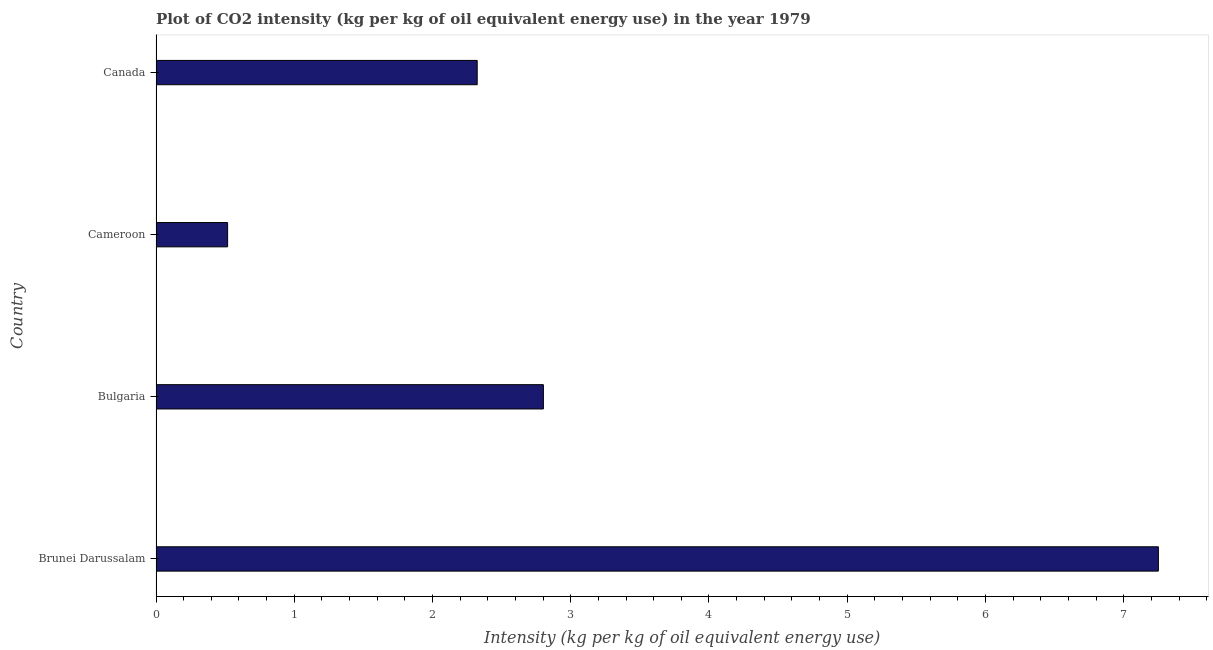Does the graph contain any zero values?
Keep it short and to the point. No. Does the graph contain grids?
Ensure brevity in your answer.  No. What is the title of the graph?
Keep it short and to the point. Plot of CO2 intensity (kg per kg of oil equivalent energy use) in the year 1979. What is the label or title of the X-axis?
Your response must be concise. Intensity (kg per kg of oil equivalent energy use). What is the label or title of the Y-axis?
Offer a very short reply. Country. What is the co2 intensity in Cameroon?
Offer a terse response. 0.52. Across all countries, what is the maximum co2 intensity?
Give a very brief answer. 7.25. Across all countries, what is the minimum co2 intensity?
Provide a short and direct response. 0.52. In which country was the co2 intensity maximum?
Your answer should be compact. Brunei Darussalam. In which country was the co2 intensity minimum?
Offer a very short reply. Cameroon. What is the sum of the co2 intensity?
Offer a terse response. 12.89. What is the difference between the co2 intensity in Brunei Darussalam and Canada?
Ensure brevity in your answer.  4.93. What is the average co2 intensity per country?
Provide a succinct answer. 3.22. What is the median co2 intensity?
Ensure brevity in your answer.  2.56. What is the ratio of the co2 intensity in Brunei Darussalam to that in Cameroon?
Ensure brevity in your answer.  14. Is the difference between the co2 intensity in Bulgaria and Cameroon greater than the difference between any two countries?
Offer a very short reply. No. What is the difference between the highest and the second highest co2 intensity?
Your answer should be very brief. 4.45. Is the sum of the co2 intensity in Brunei Darussalam and Canada greater than the maximum co2 intensity across all countries?
Keep it short and to the point. Yes. What is the difference between the highest and the lowest co2 intensity?
Ensure brevity in your answer.  6.73. Are all the bars in the graph horizontal?
Provide a succinct answer. Yes. What is the difference between two consecutive major ticks on the X-axis?
Offer a terse response. 1. What is the Intensity (kg per kg of oil equivalent energy use) of Brunei Darussalam?
Your response must be concise. 7.25. What is the Intensity (kg per kg of oil equivalent energy use) in Bulgaria?
Keep it short and to the point. 2.8. What is the Intensity (kg per kg of oil equivalent energy use) in Cameroon?
Provide a short and direct response. 0.52. What is the Intensity (kg per kg of oil equivalent energy use) in Canada?
Provide a short and direct response. 2.32. What is the difference between the Intensity (kg per kg of oil equivalent energy use) in Brunei Darussalam and Bulgaria?
Your answer should be compact. 4.45. What is the difference between the Intensity (kg per kg of oil equivalent energy use) in Brunei Darussalam and Cameroon?
Provide a succinct answer. 6.73. What is the difference between the Intensity (kg per kg of oil equivalent energy use) in Brunei Darussalam and Canada?
Provide a succinct answer. 4.93. What is the difference between the Intensity (kg per kg of oil equivalent energy use) in Bulgaria and Cameroon?
Keep it short and to the point. 2.28. What is the difference between the Intensity (kg per kg of oil equivalent energy use) in Bulgaria and Canada?
Offer a terse response. 0.48. What is the difference between the Intensity (kg per kg of oil equivalent energy use) in Cameroon and Canada?
Provide a succinct answer. -1.81. What is the ratio of the Intensity (kg per kg of oil equivalent energy use) in Brunei Darussalam to that in Bulgaria?
Give a very brief answer. 2.59. What is the ratio of the Intensity (kg per kg of oil equivalent energy use) in Brunei Darussalam to that in Cameroon?
Your answer should be compact. 14. What is the ratio of the Intensity (kg per kg of oil equivalent energy use) in Brunei Darussalam to that in Canada?
Offer a very short reply. 3.12. What is the ratio of the Intensity (kg per kg of oil equivalent energy use) in Bulgaria to that in Cameroon?
Give a very brief answer. 5.41. What is the ratio of the Intensity (kg per kg of oil equivalent energy use) in Bulgaria to that in Canada?
Your answer should be compact. 1.21. What is the ratio of the Intensity (kg per kg of oil equivalent energy use) in Cameroon to that in Canada?
Your answer should be very brief. 0.22. 